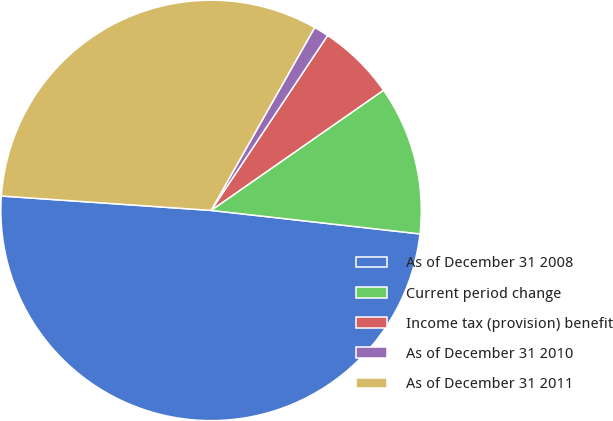Convert chart to OTSL. <chart><loc_0><loc_0><loc_500><loc_500><pie_chart><fcel>As of December 31 2008<fcel>Current period change<fcel>Income tax (provision) benefit<fcel>As of December 31 2010<fcel>As of December 31 2011<nl><fcel>49.31%<fcel>11.47%<fcel>5.96%<fcel>1.15%<fcel>32.11%<nl></chart> 